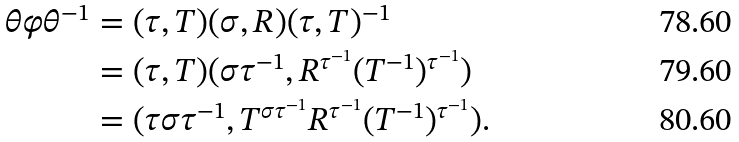Convert formula to latex. <formula><loc_0><loc_0><loc_500><loc_500>\theta \varphi \theta ^ { - 1 } & = ( \tau , T ) ( \sigma , R ) ( \tau , T ) ^ { - 1 } \\ & = ( \tau , T ) ( \sigma \tau ^ { - 1 } , R ^ { \tau ^ { - 1 } } ( T ^ { - 1 } ) ^ { \tau ^ { - 1 } } ) \\ & = ( \tau \sigma \tau ^ { - 1 } , T ^ { \sigma \tau ^ { - 1 } } R ^ { \tau ^ { - 1 } } ( T ^ { - 1 } ) ^ { \tau ^ { - 1 } } ) .</formula> 